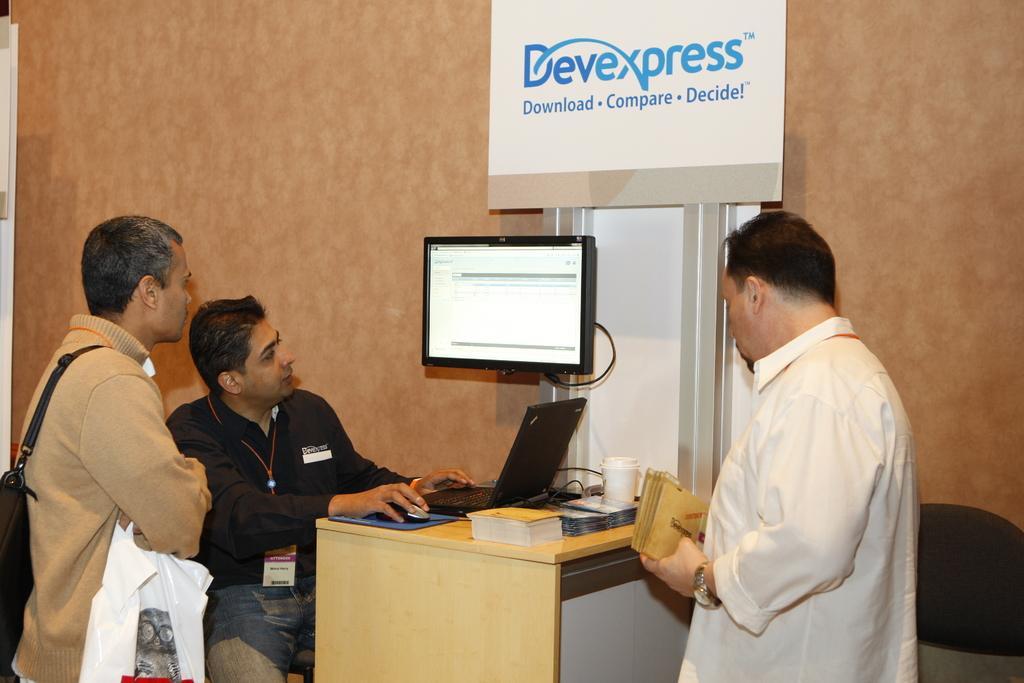Describe this image in one or two sentences. This picture describes about three people two are standing one person is seated on the chair in front of him we can see couple of objects on the table, in the left side of the image a person wearing a backpack and holding a plastic bag, and we can see some notice board here. 